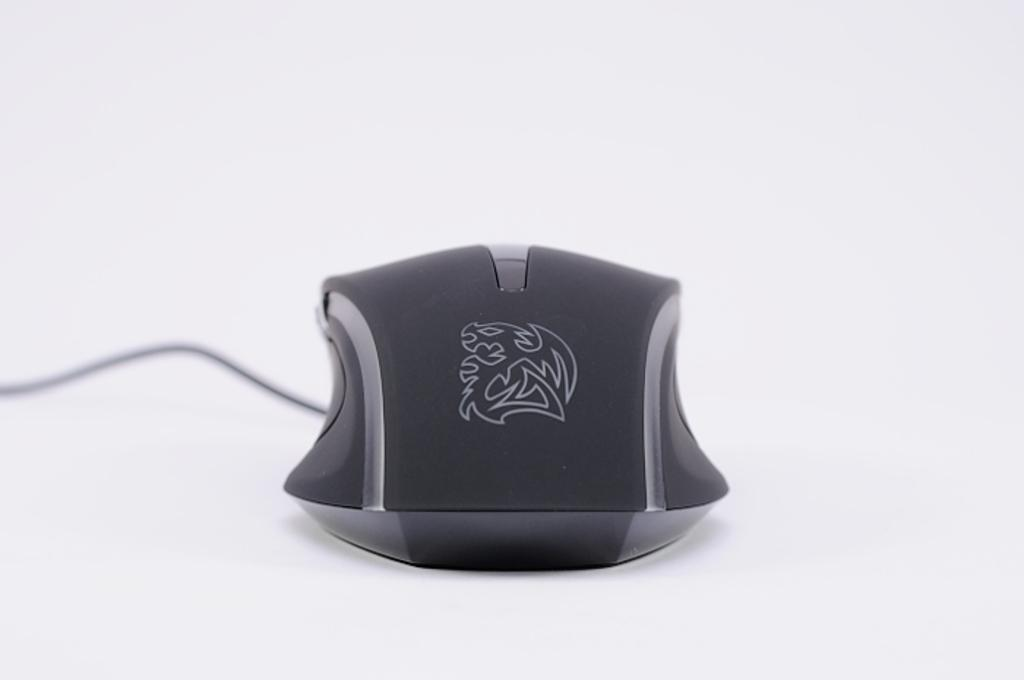What type of animal is in the image? There is a mouse in the image. Where is the mouse located? The mouse is on a platform. What type of rail can be seen in the image? There is no rail present in the image; it only features a mouse on a platform. What kind of sponge is being used by the mouse in the image? There is no sponge present in the image; it only features a mouse on a platform. 